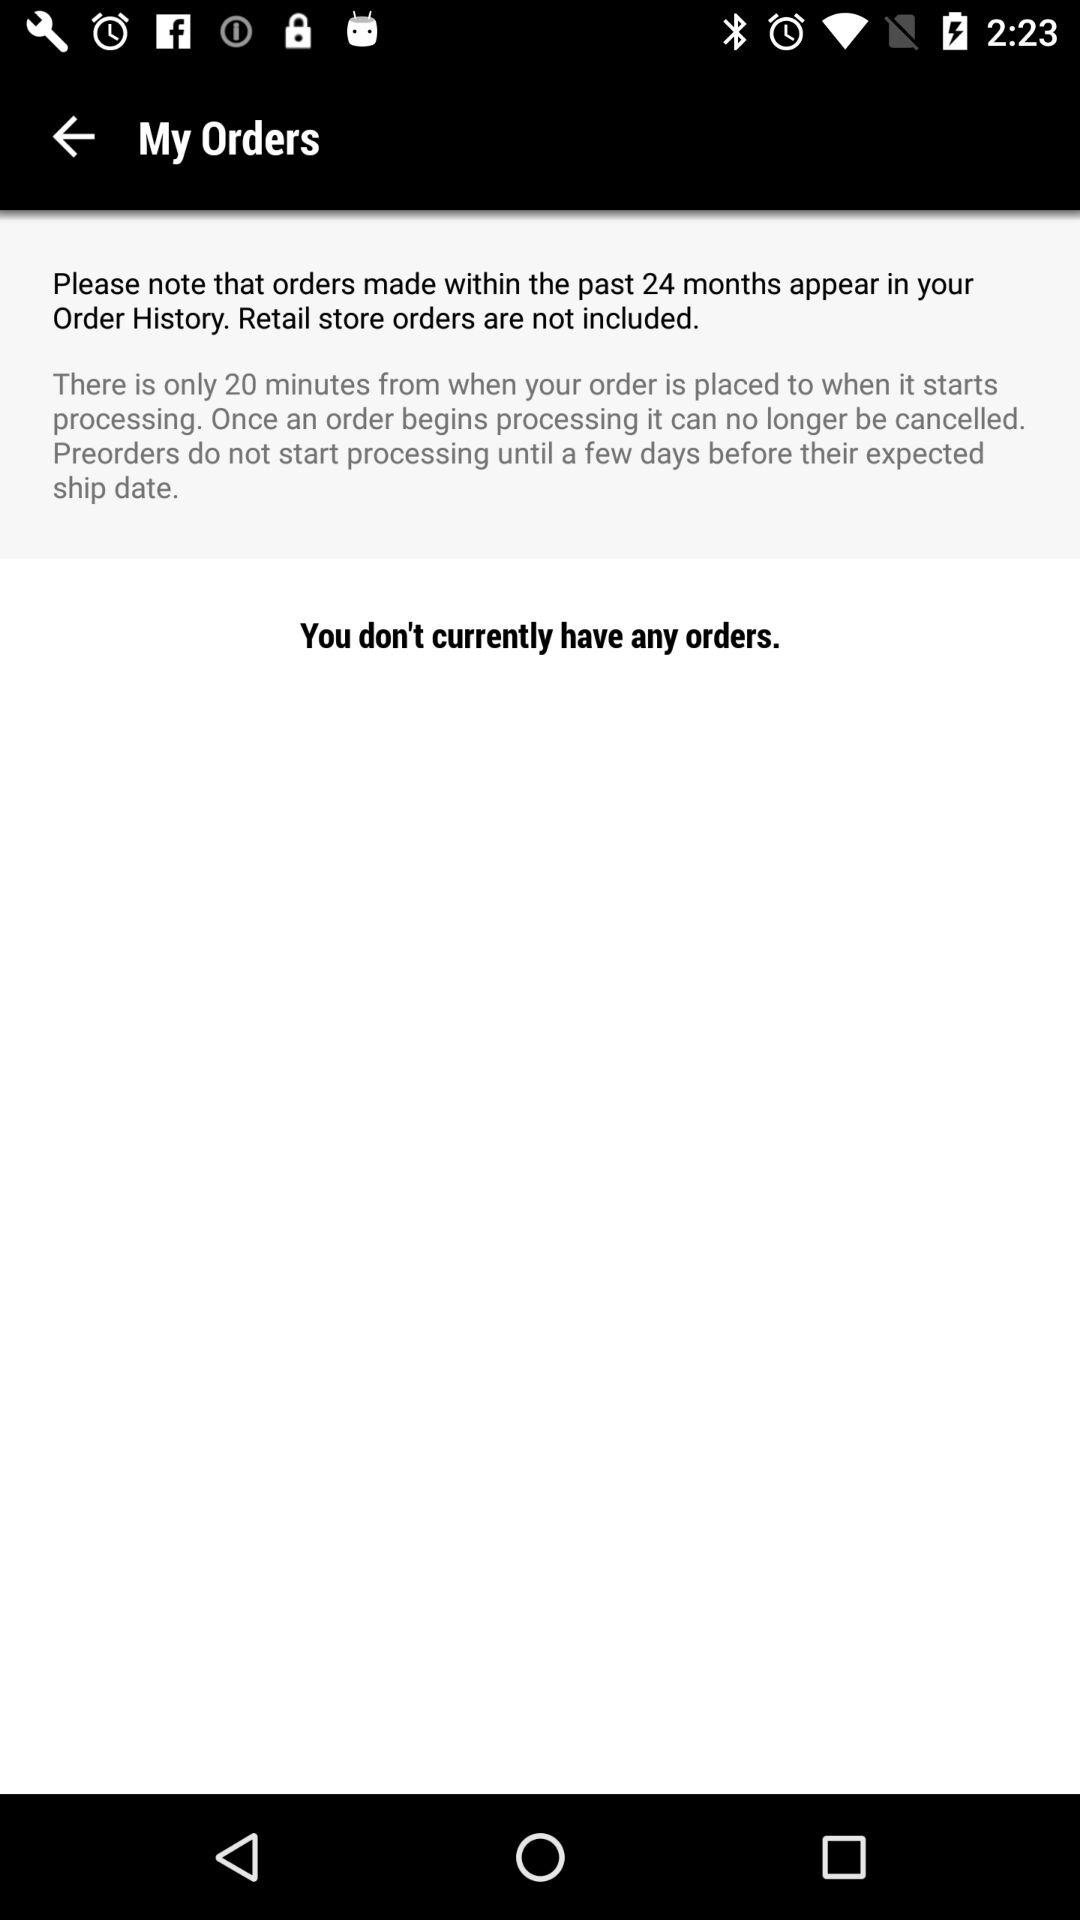For how many months does your order appear in the order history? Your order made within the past 24 months appear in your order history. 